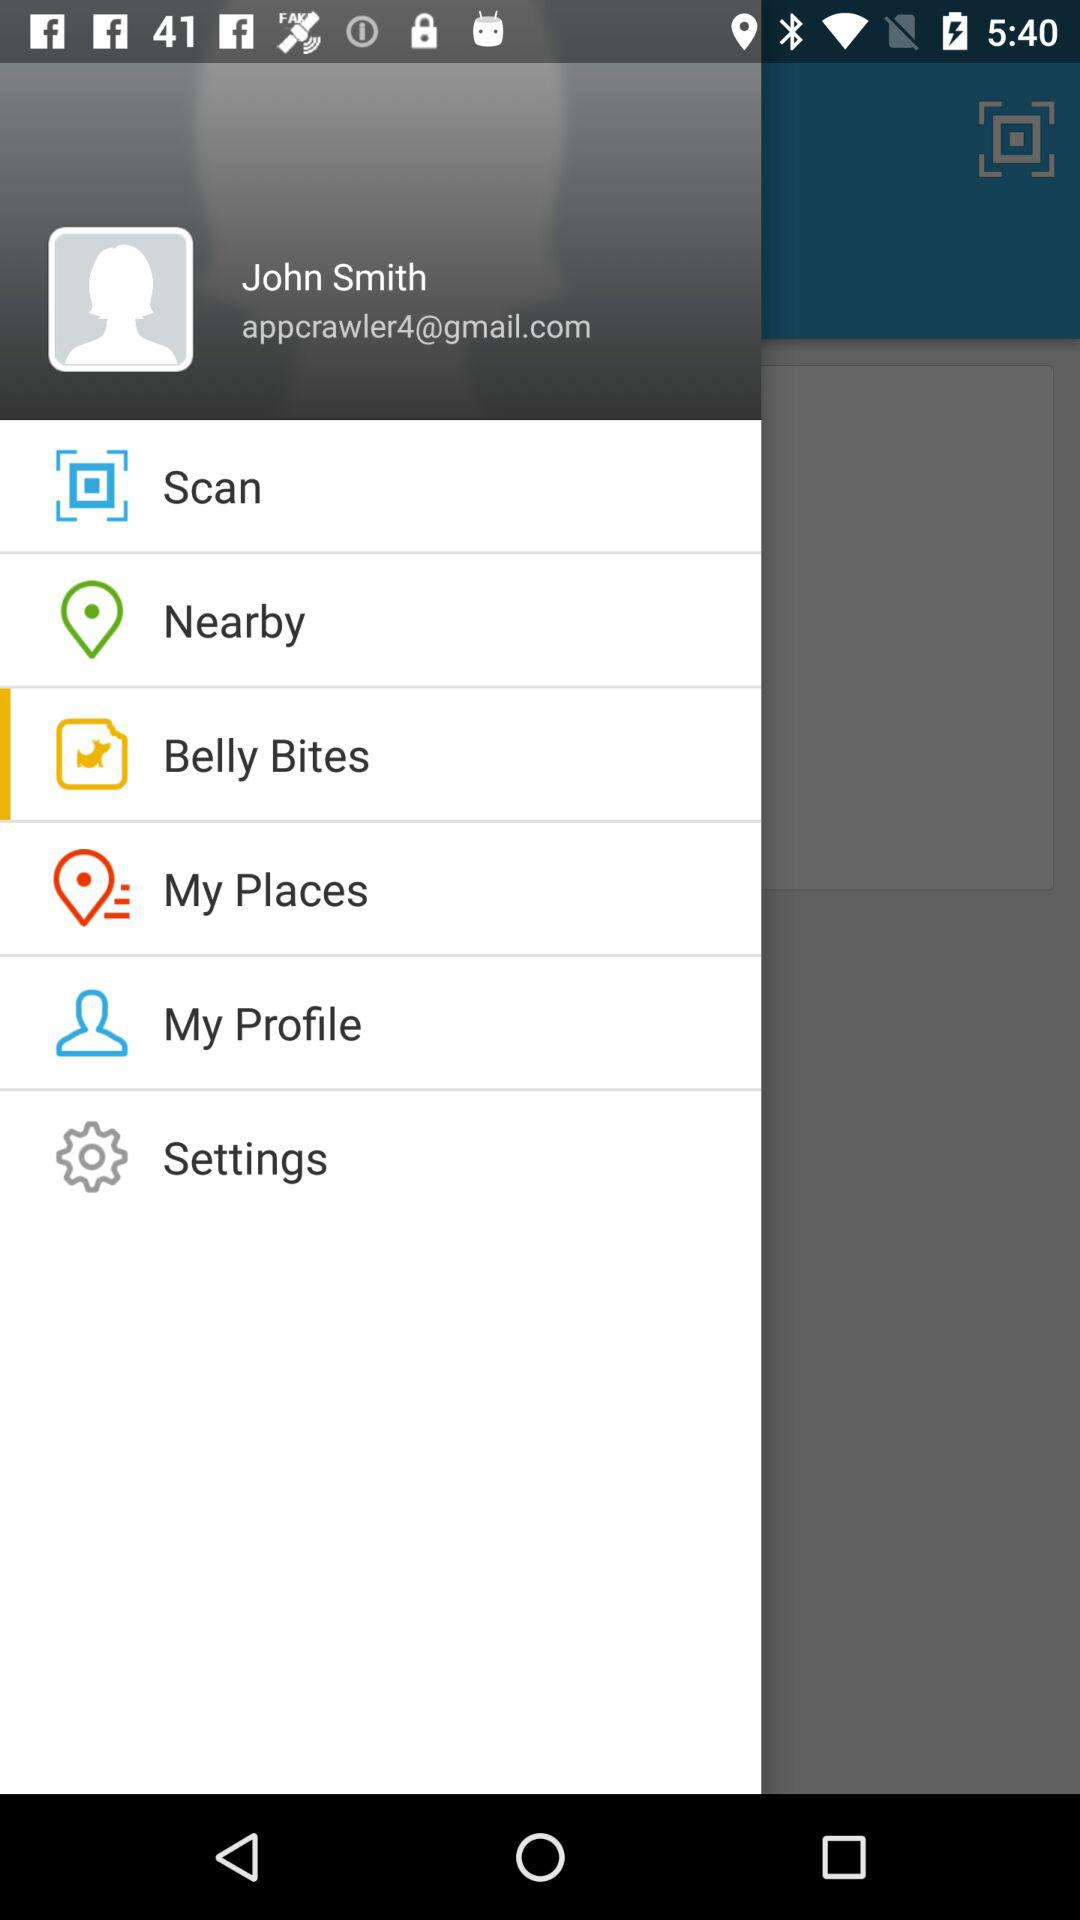What is the user name? The user name is John Smith. 